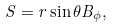<formula> <loc_0><loc_0><loc_500><loc_500>S = r \sin \theta B _ { \phi } ,</formula> 